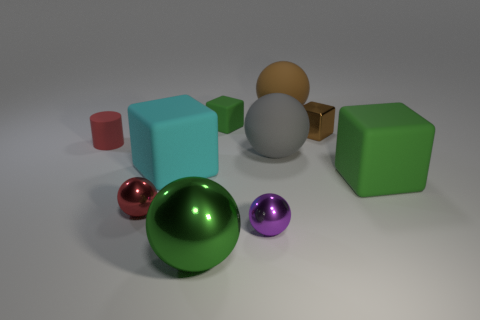If this were a scene from a story, what narrative could you imagine for these objects? This scene could represent a fantastical setting where each object holds a unique power or significance. The purple metallic ball might be a magical sphere that controls time, the green reflective sphere could be the central power source for an advanced civilization, and the cubes and cylinders might be containers for important resources or artifacts. 